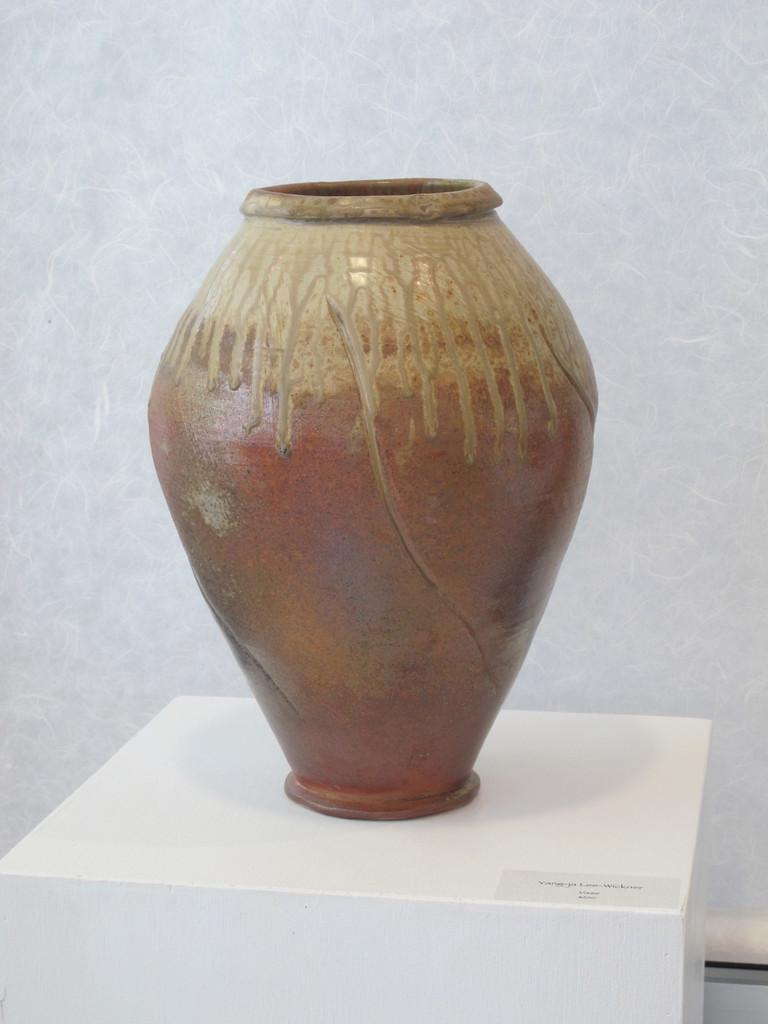What type of furniture is visible in the image? There is a table in the image. What object is placed on the table? A ceramic pot is present on the table. What can be seen in the background of the image? There is a wall in the background of the image. What type of cord is hanging from the ceiling in the image? There is no cord hanging from the ceiling in the image. Is there a battle taking place in the image? No, there is no battle depicted in the image. 